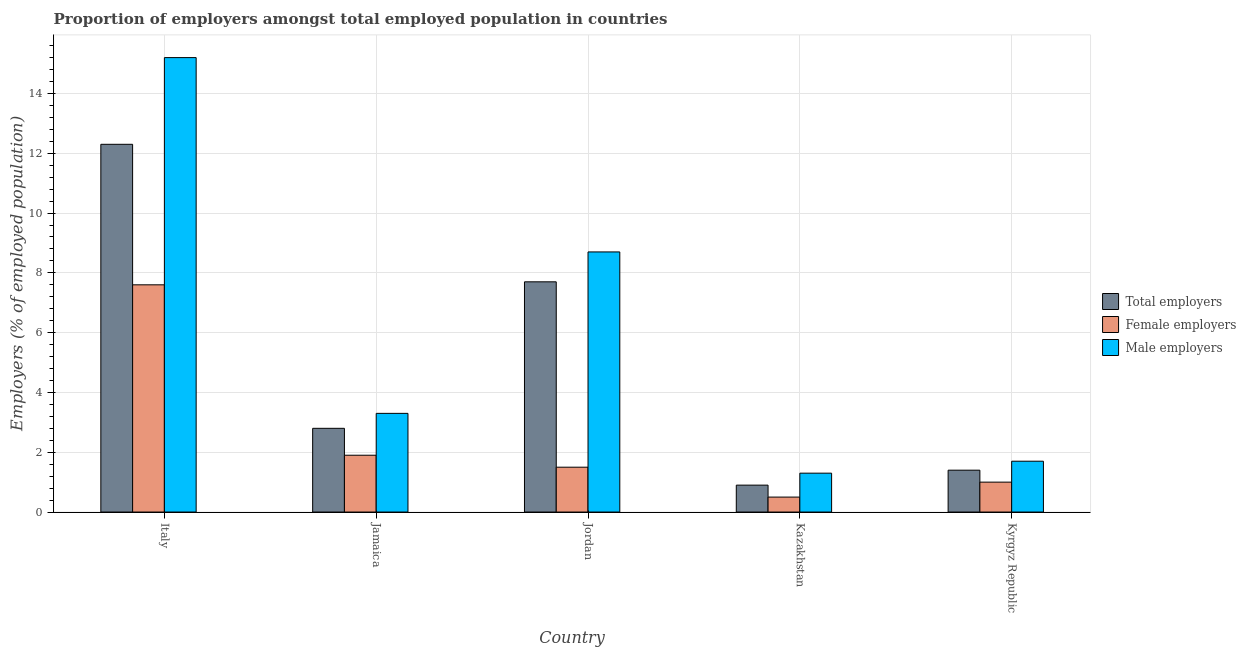How many different coloured bars are there?
Offer a terse response. 3. How many groups of bars are there?
Your response must be concise. 5. How many bars are there on the 5th tick from the right?
Ensure brevity in your answer.  3. What is the label of the 2nd group of bars from the left?
Provide a succinct answer. Jamaica. In how many cases, is the number of bars for a given country not equal to the number of legend labels?
Provide a succinct answer. 0. What is the percentage of total employers in Jordan?
Make the answer very short. 7.7. Across all countries, what is the maximum percentage of female employers?
Your answer should be very brief. 7.6. Across all countries, what is the minimum percentage of female employers?
Offer a very short reply. 0.5. In which country was the percentage of total employers maximum?
Provide a succinct answer. Italy. In which country was the percentage of male employers minimum?
Provide a short and direct response. Kazakhstan. What is the total percentage of female employers in the graph?
Make the answer very short. 12.5. What is the difference between the percentage of total employers in Jamaica and that in Jordan?
Ensure brevity in your answer.  -4.9. What is the difference between the percentage of total employers in Kazakhstan and the percentage of male employers in Kyrgyz Republic?
Give a very brief answer. -0.8. What is the average percentage of total employers per country?
Provide a short and direct response. 5.02. What is the difference between the percentage of male employers and percentage of female employers in Kyrgyz Republic?
Ensure brevity in your answer.  0.7. What is the ratio of the percentage of total employers in Italy to that in Kazakhstan?
Keep it short and to the point. 13.67. Is the percentage of male employers in Jamaica less than that in Kazakhstan?
Make the answer very short. No. Is the difference between the percentage of female employers in Jordan and Kyrgyz Republic greater than the difference between the percentage of male employers in Jordan and Kyrgyz Republic?
Ensure brevity in your answer.  No. What is the difference between the highest and the second highest percentage of female employers?
Offer a very short reply. 5.7. What is the difference between the highest and the lowest percentage of male employers?
Provide a short and direct response. 13.9. In how many countries, is the percentage of female employers greater than the average percentage of female employers taken over all countries?
Offer a very short reply. 1. What does the 3rd bar from the left in Jamaica represents?
Provide a short and direct response. Male employers. What does the 2nd bar from the right in Jordan represents?
Keep it short and to the point. Female employers. Is it the case that in every country, the sum of the percentage of total employers and percentage of female employers is greater than the percentage of male employers?
Your answer should be very brief. Yes. Are the values on the major ticks of Y-axis written in scientific E-notation?
Keep it short and to the point. No. Does the graph contain any zero values?
Ensure brevity in your answer.  No. Does the graph contain grids?
Offer a terse response. Yes. How many legend labels are there?
Your answer should be very brief. 3. How are the legend labels stacked?
Give a very brief answer. Vertical. What is the title of the graph?
Give a very brief answer. Proportion of employers amongst total employed population in countries. What is the label or title of the X-axis?
Make the answer very short. Country. What is the label or title of the Y-axis?
Keep it short and to the point. Employers (% of employed population). What is the Employers (% of employed population) in Total employers in Italy?
Provide a succinct answer. 12.3. What is the Employers (% of employed population) in Female employers in Italy?
Make the answer very short. 7.6. What is the Employers (% of employed population) in Male employers in Italy?
Provide a succinct answer. 15.2. What is the Employers (% of employed population) in Total employers in Jamaica?
Make the answer very short. 2.8. What is the Employers (% of employed population) of Female employers in Jamaica?
Your answer should be very brief. 1.9. What is the Employers (% of employed population) of Male employers in Jamaica?
Give a very brief answer. 3.3. What is the Employers (% of employed population) in Total employers in Jordan?
Ensure brevity in your answer.  7.7. What is the Employers (% of employed population) in Male employers in Jordan?
Make the answer very short. 8.7. What is the Employers (% of employed population) of Total employers in Kazakhstan?
Offer a very short reply. 0.9. What is the Employers (% of employed population) of Female employers in Kazakhstan?
Keep it short and to the point. 0.5. What is the Employers (% of employed population) of Male employers in Kazakhstan?
Provide a short and direct response. 1.3. What is the Employers (% of employed population) of Total employers in Kyrgyz Republic?
Your response must be concise. 1.4. What is the Employers (% of employed population) in Male employers in Kyrgyz Republic?
Offer a terse response. 1.7. Across all countries, what is the maximum Employers (% of employed population) in Total employers?
Give a very brief answer. 12.3. Across all countries, what is the maximum Employers (% of employed population) in Female employers?
Provide a succinct answer. 7.6. Across all countries, what is the maximum Employers (% of employed population) in Male employers?
Offer a terse response. 15.2. Across all countries, what is the minimum Employers (% of employed population) of Total employers?
Provide a succinct answer. 0.9. Across all countries, what is the minimum Employers (% of employed population) in Female employers?
Give a very brief answer. 0.5. Across all countries, what is the minimum Employers (% of employed population) of Male employers?
Make the answer very short. 1.3. What is the total Employers (% of employed population) of Total employers in the graph?
Provide a succinct answer. 25.1. What is the total Employers (% of employed population) in Male employers in the graph?
Offer a very short reply. 30.2. What is the difference between the Employers (% of employed population) of Total employers in Italy and that in Jamaica?
Offer a very short reply. 9.5. What is the difference between the Employers (% of employed population) of Female employers in Italy and that in Jamaica?
Provide a short and direct response. 5.7. What is the difference between the Employers (% of employed population) in Total employers in Italy and that in Jordan?
Keep it short and to the point. 4.6. What is the difference between the Employers (% of employed population) in Female employers in Italy and that in Jordan?
Offer a terse response. 6.1. What is the difference between the Employers (% of employed population) in Male employers in Italy and that in Jordan?
Your answer should be compact. 6.5. What is the difference between the Employers (% of employed population) of Total employers in Italy and that in Kazakhstan?
Offer a terse response. 11.4. What is the difference between the Employers (% of employed population) of Male employers in Italy and that in Kazakhstan?
Offer a very short reply. 13.9. What is the difference between the Employers (% of employed population) in Total employers in Italy and that in Kyrgyz Republic?
Offer a very short reply. 10.9. What is the difference between the Employers (% of employed population) in Female employers in Jamaica and that in Jordan?
Your answer should be very brief. 0.4. What is the difference between the Employers (% of employed population) of Total employers in Jamaica and that in Kazakhstan?
Give a very brief answer. 1.9. What is the difference between the Employers (% of employed population) in Female employers in Jamaica and that in Kazakhstan?
Ensure brevity in your answer.  1.4. What is the difference between the Employers (% of employed population) of Total employers in Jordan and that in Kazakhstan?
Give a very brief answer. 6.8. What is the difference between the Employers (% of employed population) of Female employers in Jordan and that in Kyrgyz Republic?
Ensure brevity in your answer.  0.5. What is the difference between the Employers (% of employed population) of Total employers in Kazakhstan and that in Kyrgyz Republic?
Give a very brief answer. -0.5. What is the difference between the Employers (% of employed population) in Total employers in Italy and the Employers (% of employed population) in Male employers in Jamaica?
Provide a succinct answer. 9. What is the difference between the Employers (% of employed population) of Total employers in Italy and the Employers (% of employed population) of Female employers in Jordan?
Your answer should be compact. 10.8. What is the difference between the Employers (% of employed population) in Female employers in Italy and the Employers (% of employed population) in Male employers in Jordan?
Make the answer very short. -1.1. What is the difference between the Employers (% of employed population) of Total employers in Italy and the Employers (% of employed population) of Male employers in Kazakhstan?
Give a very brief answer. 11. What is the difference between the Employers (% of employed population) of Total employers in Italy and the Employers (% of employed population) of Female employers in Kyrgyz Republic?
Make the answer very short. 11.3. What is the difference between the Employers (% of employed population) of Female employers in Italy and the Employers (% of employed population) of Male employers in Kyrgyz Republic?
Give a very brief answer. 5.9. What is the difference between the Employers (% of employed population) in Total employers in Jamaica and the Employers (% of employed population) in Female employers in Jordan?
Make the answer very short. 1.3. What is the difference between the Employers (% of employed population) in Total employers in Jamaica and the Employers (% of employed population) in Female employers in Kyrgyz Republic?
Offer a terse response. 1.8. What is the difference between the Employers (% of employed population) of Total employers in Jamaica and the Employers (% of employed population) of Male employers in Kyrgyz Republic?
Provide a succinct answer. 1.1. What is the difference between the Employers (% of employed population) of Total employers in Jordan and the Employers (% of employed population) of Female employers in Kazakhstan?
Ensure brevity in your answer.  7.2. What is the difference between the Employers (% of employed population) of Total employers in Jordan and the Employers (% of employed population) of Male employers in Kazakhstan?
Your response must be concise. 6.4. What is the difference between the Employers (% of employed population) of Total employers in Jordan and the Employers (% of employed population) of Female employers in Kyrgyz Republic?
Provide a short and direct response. 6.7. What is the average Employers (% of employed population) of Total employers per country?
Provide a succinct answer. 5.02. What is the average Employers (% of employed population) of Male employers per country?
Offer a terse response. 6.04. What is the difference between the Employers (% of employed population) in Total employers and Employers (% of employed population) in Female employers in Italy?
Your response must be concise. 4.7. What is the difference between the Employers (% of employed population) of Total employers and Employers (% of employed population) of Male employers in Italy?
Your response must be concise. -2.9. What is the difference between the Employers (% of employed population) of Female employers and Employers (% of employed population) of Male employers in Italy?
Make the answer very short. -7.6. What is the difference between the Employers (% of employed population) in Female employers and Employers (% of employed population) in Male employers in Jamaica?
Make the answer very short. -1.4. What is the difference between the Employers (% of employed population) of Total employers and Employers (% of employed population) of Female employers in Jordan?
Provide a short and direct response. 6.2. What is the difference between the Employers (% of employed population) in Total employers and Employers (% of employed population) in Male employers in Jordan?
Give a very brief answer. -1. What is the difference between the Employers (% of employed population) in Total employers and Employers (% of employed population) in Female employers in Kazakhstan?
Give a very brief answer. 0.4. What is the difference between the Employers (% of employed population) of Female employers and Employers (% of employed population) of Male employers in Kazakhstan?
Provide a short and direct response. -0.8. What is the difference between the Employers (% of employed population) in Total employers and Employers (% of employed population) in Male employers in Kyrgyz Republic?
Provide a succinct answer. -0.3. What is the difference between the Employers (% of employed population) of Female employers and Employers (% of employed population) of Male employers in Kyrgyz Republic?
Your answer should be very brief. -0.7. What is the ratio of the Employers (% of employed population) of Total employers in Italy to that in Jamaica?
Give a very brief answer. 4.39. What is the ratio of the Employers (% of employed population) of Female employers in Italy to that in Jamaica?
Keep it short and to the point. 4. What is the ratio of the Employers (% of employed population) of Male employers in Italy to that in Jamaica?
Your answer should be very brief. 4.61. What is the ratio of the Employers (% of employed population) in Total employers in Italy to that in Jordan?
Offer a very short reply. 1.6. What is the ratio of the Employers (% of employed population) in Female employers in Italy to that in Jordan?
Provide a short and direct response. 5.07. What is the ratio of the Employers (% of employed population) in Male employers in Italy to that in Jordan?
Provide a succinct answer. 1.75. What is the ratio of the Employers (% of employed population) in Total employers in Italy to that in Kazakhstan?
Offer a very short reply. 13.67. What is the ratio of the Employers (% of employed population) of Female employers in Italy to that in Kazakhstan?
Keep it short and to the point. 15.2. What is the ratio of the Employers (% of employed population) of Male employers in Italy to that in Kazakhstan?
Provide a short and direct response. 11.69. What is the ratio of the Employers (% of employed population) in Total employers in Italy to that in Kyrgyz Republic?
Provide a succinct answer. 8.79. What is the ratio of the Employers (% of employed population) in Male employers in Italy to that in Kyrgyz Republic?
Offer a very short reply. 8.94. What is the ratio of the Employers (% of employed population) in Total employers in Jamaica to that in Jordan?
Offer a terse response. 0.36. What is the ratio of the Employers (% of employed population) of Female employers in Jamaica to that in Jordan?
Your response must be concise. 1.27. What is the ratio of the Employers (% of employed population) of Male employers in Jamaica to that in Jordan?
Your answer should be compact. 0.38. What is the ratio of the Employers (% of employed population) in Total employers in Jamaica to that in Kazakhstan?
Offer a very short reply. 3.11. What is the ratio of the Employers (% of employed population) in Female employers in Jamaica to that in Kazakhstan?
Provide a succinct answer. 3.8. What is the ratio of the Employers (% of employed population) of Male employers in Jamaica to that in Kazakhstan?
Provide a short and direct response. 2.54. What is the ratio of the Employers (% of employed population) of Male employers in Jamaica to that in Kyrgyz Republic?
Provide a succinct answer. 1.94. What is the ratio of the Employers (% of employed population) of Total employers in Jordan to that in Kazakhstan?
Offer a terse response. 8.56. What is the ratio of the Employers (% of employed population) in Male employers in Jordan to that in Kazakhstan?
Provide a short and direct response. 6.69. What is the ratio of the Employers (% of employed population) in Total employers in Jordan to that in Kyrgyz Republic?
Offer a very short reply. 5.5. What is the ratio of the Employers (% of employed population) of Female employers in Jordan to that in Kyrgyz Republic?
Give a very brief answer. 1.5. What is the ratio of the Employers (% of employed population) of Male employers in Jordan to that in Kyrgyz Republic?
Offer a terse response. 5.12. What is the ratio of the Employers (% of employed population) of Total employers in Kazakhstan to that in Kyrgyz Republic?
Your answer should be very brief. 0.64. What is the ratio of the Employers (% of employed population) of Male employers in Kazakhstan to that in Kyrgyz Republic?
Offer a very short reply. 0.76. What is the difference between the highest and the lowest Employers (% of employed population) in Total employers?
Give a very brief answer. 11.4. What is the difference between the highest and the lowest Employers (% of employed population) of Male employers?
Your answer should be compact. 13.9. 